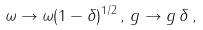Convert formula to latex. <formula><loc_0><loc_0><loc_500><loc_500>\omega \to \omega ( 1 - \delta ) ^ { 1 / 2 } \, , \, g \to g \, \delta \, ,</formula> 